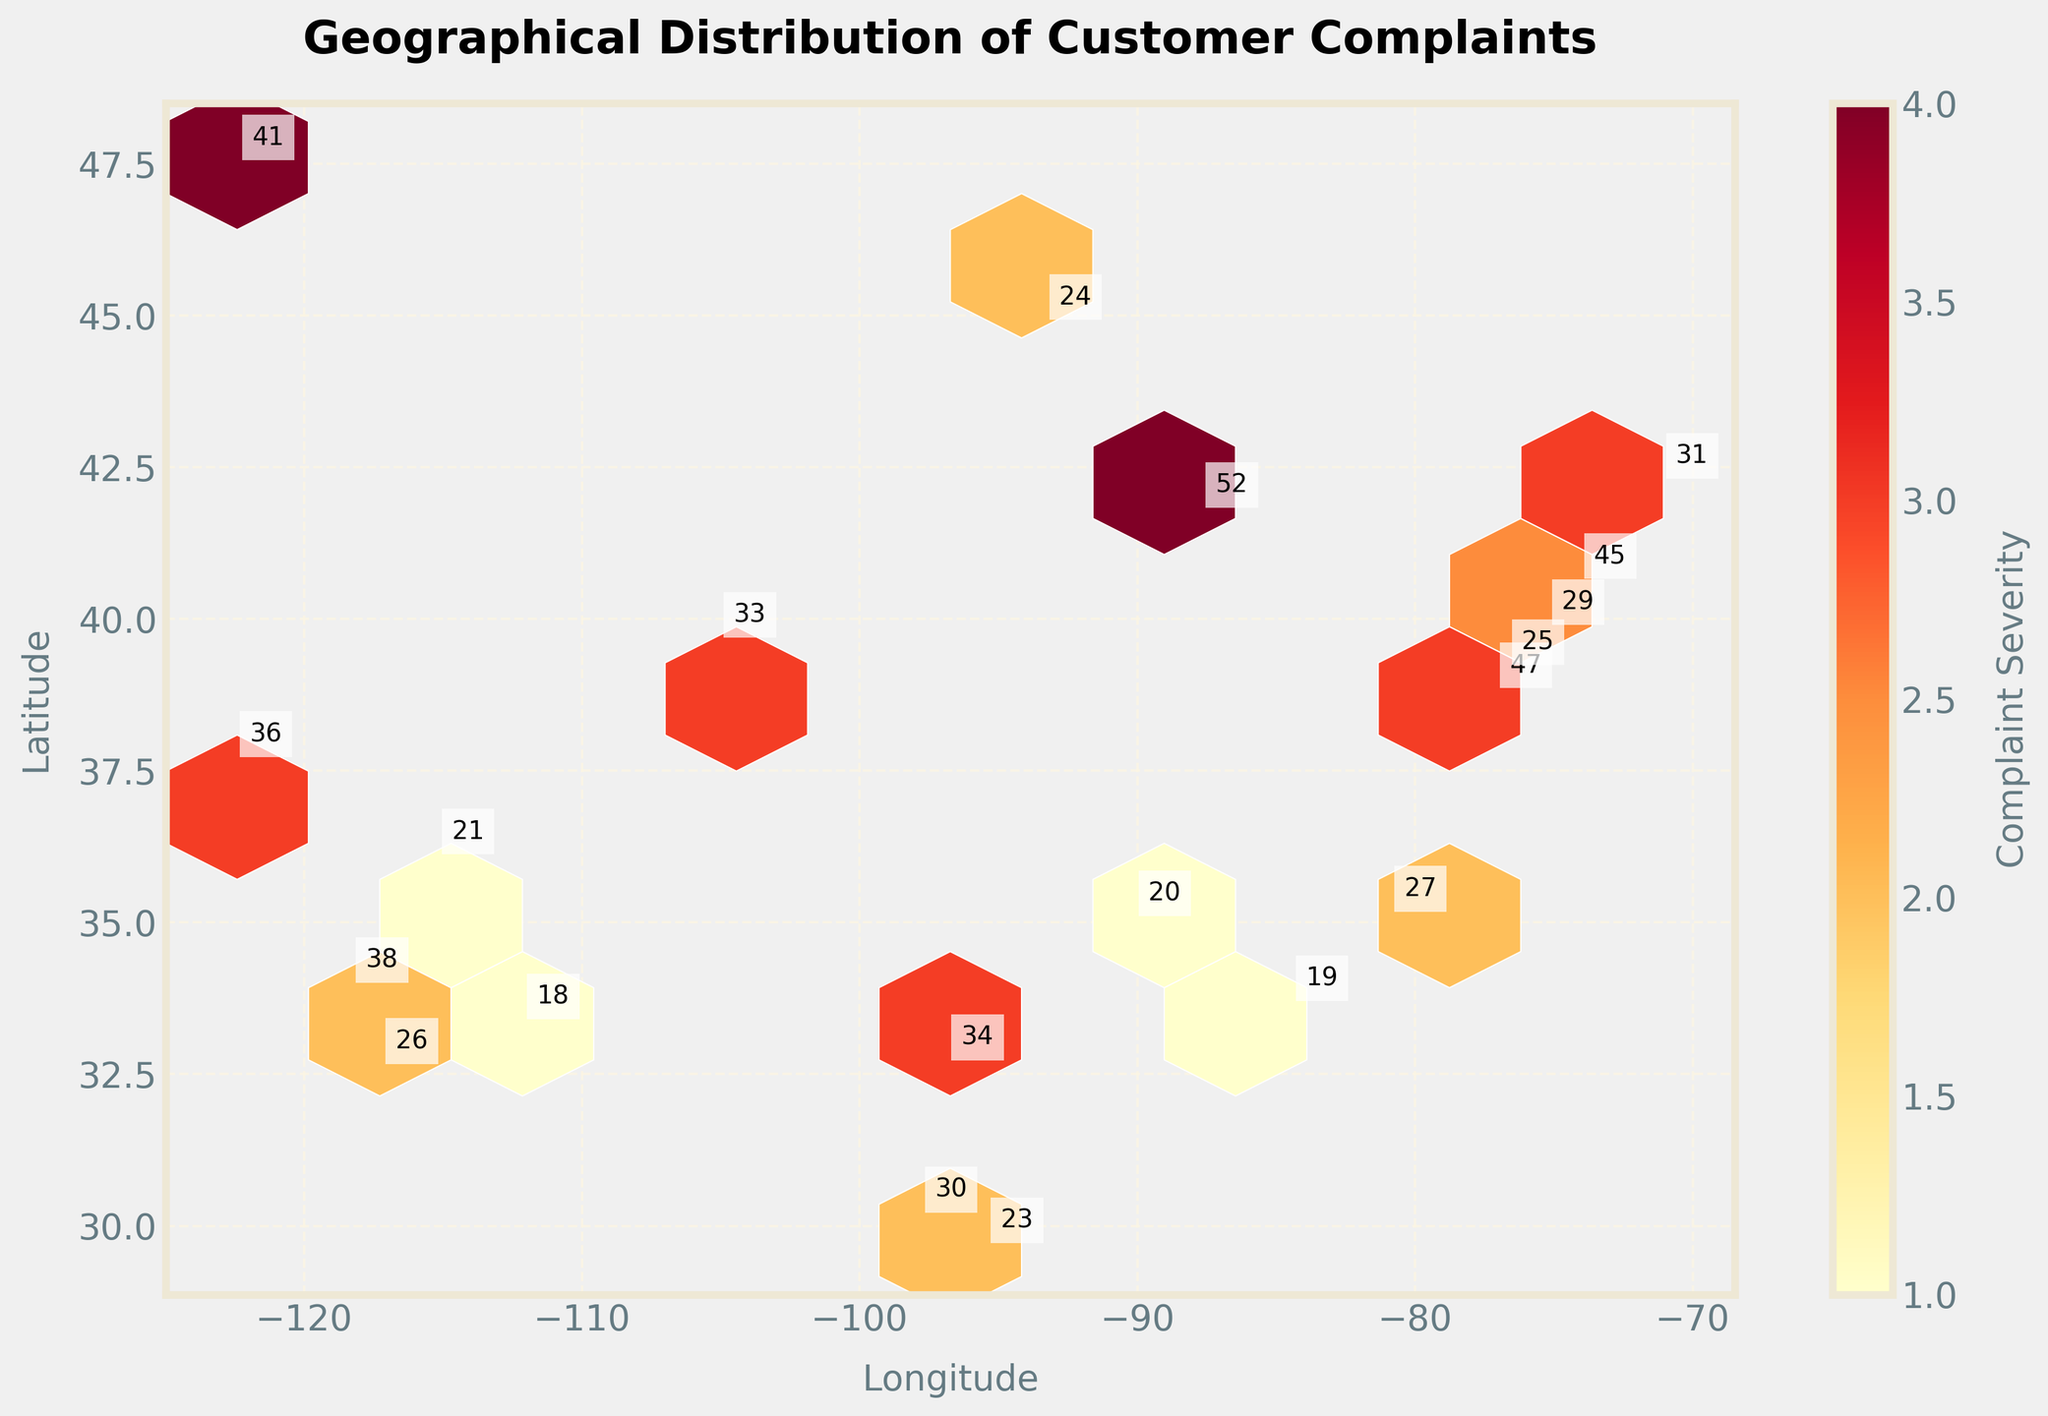What is the title of the Hexbin plot? The title is displayed at the top of the plot and indicates what the figure is about.
Answer: Geographical Distribution of Customer Complaints What are the labels of the x-axis and y-axis? The x-axis and y-axis labels are given to provide context about the plotted data's dimensions. The x-axis represents longitudinal coordinates, and the y-axis represents latitudinal coordinates.
Answer: Longitude, Latitude How many data points are there in the plot? By annotating each point with the complaint count, the number of annotations equals the number of data points. We count each annotation in the plot.
Answer: 20 What is the color scale representing? The color scale (color bar) on the right of the plot indicates what the color variations represent. It usually denotes the value of a parameter. In this case, it is labeled with "Complaint Severity."
Answer: Complaint Severity Which coordinate has the highest complaint severity? We need to find the hexbin with the darkest shade of the color corresponding to the highest severity. By looking at the hexbins and the color bar scale, we identify the darkest hexbin's location. The severity annotations can assist as well.
Answer: (41.8781, -87.6298) Compare the complaint severity levels between New York (40.7128, -74.0060) and Los Angeles (34.0522, -118.2437). Which city has a higher complaint severity level? We find the annotated severity levels for both New York and Los Angeles in the plot. By comparing these annotations, we determine which city has a higher severity level.
Answer: New York What is the average complaint severity level for all plotted locations? Sum all the severity levels from the plot and divide by the number of data points (20). Using the severity levels from the annotations: (3+2+4+1+3+2+1+4+2+3+1+2+3+1+2+3+4+2+1+3) = 49, and the average is 49/20 = 2.45.
Answer: 2.45 How many plotted locations have a severity level of 4? We count the points annotated with a severity level of 4 in the plot.
Answer: 4 What is the complaint count at San Francisco (37.7749, -122.4194)? We look for the annotation near the coordinates (37.7749, -122.4194) and read its complaint count.
Answer: 36 Is there a clear geographical region with higher complaint severity levels? By interpreting the color intensity and density of the hexbins, we can assess if higher severity complaints are clustered in a specific geographic region or spread out. Darker and more dense hexbins indicate higher severity levels.
Answer: Midwest and East Coast U.S 